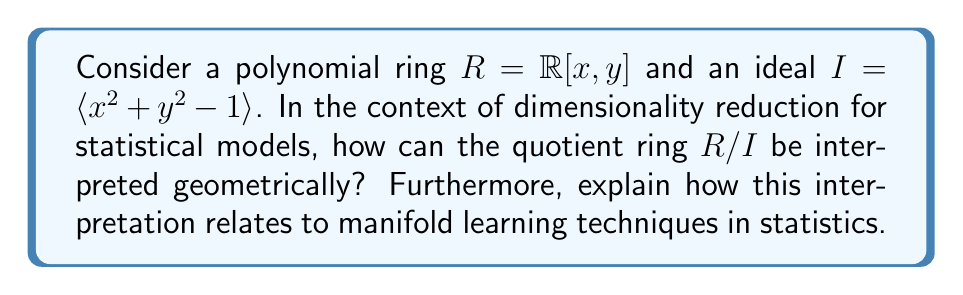Can you solve this math problem? To understand this problem, let's break it down step-by-step:

1) The polynomial ring $R = \mathbb{R}[x, y]$ represents all polynomials in two variables $x$ and $y$ with real coefficients.

2) The ideal $I = \langle x^2 + y^2 - 1 \rangle$ is generated by the polynomial $x^2 + y^2 - 1$.

3) The quotient ring $R/I$ consists of equivalence classes of polynomials, where two polynomials are equivalent if their difference is in the ideal $I$.

4) Geometrically, the equation $x^2 + y^2 - 1 = 0$ represents a unit circle in the xy-plane.

5) In the quotient ring $R/I$, all polynomials that differ by multiples of $x^2 + y^2 - 1$ are considered equivalent. This means that, geometrically, we're identifying all points in $\mathbb{R}^2$ that lie on the same radius from the origin.

6) Therefore, $R/I$ can be interpreted as the unit circle itself. Each element of $R/I$ corresponds to a point on the unit circle.

7) In terms of dimensionality reduction, this process has effectively reduced a two-dimensional space ($\mathbb{R}^2$) to a one-dimensional manifold (the circle).

8) This relates to manifold learning techniques in statistics, such as Isomap or Locally Linear Embedding (LLE), which aim to discover low-dimensional manifolds embedded in high-dimensional spaces.

9) Just as the quotient ring $R/I$ captures the essential structure of the circle while reducing dimensionality, manifold learning techniques in statistics attempt to capture the underlying structure of data while reducing its dimensionality.

10) The quotient ring approach provides a rigorous algebraic framework for understanding these dimensionality reduction techniques, potentially offering new insights into their properties and limitations.
Answer: The quotient ring $R/I$ can be geometrically interpreted as the unit circle in $\mathbb{R}^2$. This interpretation relates to manifold learning techniques in statistics by demonstrating how a higher-dimensional space (2D in this case) can be reduced to a lower-dimensional manifold (1D circle) while preserving essential structure, which is the fundamental principle behind many dimensionality reduction methods in statistical modeling. 